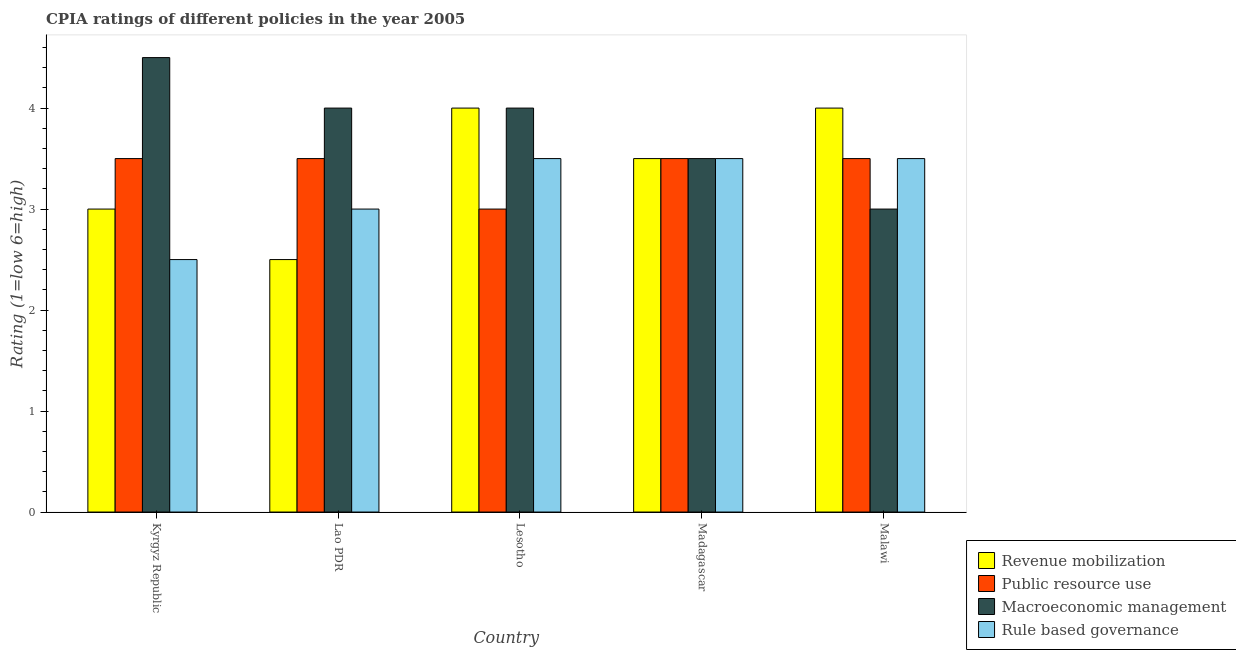How many groups of bars are there?
Your answer should be compact. 5. Are the number of bars per tick equal to the number of legend labels?
Make the answer very short. Yes. How many bars are there on the 2nd tick from the right?
Keep it short and to the point. 4. What is the label of the 4th group of bars from the left?
Give a very brief answer. Madagascar. Across all countries, what is the maximum cpia rating of public resource use?
Offer a very short reply. 3.5. In which country was the cpia rating of revenue mobilization maximum?
Make the answer very short. Lesotho. In which country was the cpia rating of rule based governance minimum?
Offer a terse response. Kyrgyz Republic. What is the total cpia rating of revenue mobilization in the graph?
Give a very brief answer. 17. What is the difference between the cpia rating of public resource use and cpia rating of macroeconomic management in Lesotho?
Provide a short and direct response. -1. In how many countries, is the cpia rating of macroeconomic management greater than 3.2 ?
Provide a succinct answer. 4. What is the ratio of the cpia rating of rule based governance in Lao PDR to that in Lesotho?
Provide a short and direct response. 0.86. Is the cpia rating of revenue mobilization in Kyrgyz Republic less than that in Lesotho?
Make the answer very short. Yes. What is the difference between the highest and the second highest cpia rating of revenue mobilization?
Offer a very short reply. 0. In how many countries, is the cpia rating of macroeconomic management greater than the average cpia rating of macroeconomic management taken over all countries?
Your response must be concise. 3. Is the sum of the cpia rating of public resource use in Kyrgyz Republic and Lesotho greater than the maximum cpia rating of rule based governance across all countries?
Give a very brief answer. Yes. What does the 2nd bar from the left in Kyrgyz Republic represents?
Ensure brevity in your answer.  Public resource use. What does the 2nd bar from the right in Kyrgyz Republic represents?
Provide a succinct answer. Macroeconomic management. Is it the case that in every country, the sum of the cpia rating of revenue mobilization and cpia rating of public resource use is greater than the cpia rating of macroeconomic management?
Keep it short and to the point. Yes. How many bars are there?
Offer a very short reply. 20. Are all the bars in the graph horizontal?
Keep it short and to the point. No. How many countries are there in the graph?
Ensure brevity in your answer.  5. What is the difference between two consecutive major ticks on the Y-axis?
Offer a very short reply. 1. Are the values on the major ticks of Y-axis written in scientific E-notation?
Offer a terse response. No. Where does the legend appear in the graph?
Provide a short and direct response. Bottom right. How many legend labels are there?
Your answer should be very brief. 4. What is the title of the graph?
Offer a very short reply. CPIA ratings of different policies in the year 2005. Does "Others" appear as one of the legend labels in the graph?
Provide a short and direct response. No. What is the label or title of the X-axis?
Your response must be concise. Country. What is the label or title of the Y-axis?
Provide a succinct answer. Rating (1=low 6=high). What is the Rating (1=low 6=high) of Revenue mobilization in Kyrgyz Republic?
Provide a short and direct response. 3. What is the Rating (1=low 6=high) in Revenue mobilization in Lao PDR?
Provide a succinct answer. 2.5. What is the Rating (1=low 6=high) in Public resource use in Lao PDR?
Your response must be concise. 3.5. What is the Rating (1=low 6=high) of Macroeconomic management in Lesotho?
Make the answer very short. 4. What is the Rating (1=low 6=high) of Rule based governance in Lesotho?
Your answer should be very brief. 3.5. What is the Rating (1=low 6=high) of Revenue mobilization in Madagascar?
Your answer should be very brief. 3.5. What is the Rating (1=low 6=high) of Public resource use in Malawi?
Your response must be concise. 3.5. What is the Rating (1=low 6=high) of Rule based governance in Malawi?
Provide a short and direct response. 3.5. Across all countries, what is the minimum Rating (1=low 6=high) in Revenue mobilization?
Offer a very short reply. 2.5. Across all countries, what is the minimum Rating (1=low 6=high) of Macroeconomic management?
Keep it short and to the point. 3. Across all countries, what is the minimum Rating (1=low 6=high) in Rule based governance?
Ensure brevity in your answer.  2.5. What is the total Rating (1=low 6=high) in Revenue mobilization in the graph?
Give a very brief answer. 17. What is the total Rating (1=low 6=high) of Public resource use in the graph?
Offer a terse response. 17. What is the total Rating (1=low 6=high) in Macroeconomic management in the graph?
Offer a terse response. 19. What is the difference between the Rating (1=low 6=high) in Revenue mobilization in Kyrgyz Republic and that in Lao PDR?
Offer a terse response. 0.5. What is the difference between the Rating (1=low 6=high) in Public resource use in Kyrgyz Republic and that in Lesotho?
Make the answer very short. 0.5. What is the difference between the Rating (1=low 6=high) in Macroeconomic management in Kyrgyz Republic and that in Lesotho?
Your answer should be very brief. 0.5. What is the difference between the Rating (1=low 6=high) of Rule based governance in Kyrgyz Republic and that in Lesotho?
Ensure brevity in your answer.  -1. What is the difference between the Rating (1=low 6=high) of Revenue mobilization in Kyrgyz Republic and that in Madagascar?
Your answer should be very brief. -0.5. What is the difference between the Rating (1=low 6=high) in Macroeconomic management in Kyrgyz Republic and that in Madagascar?
Provide a short and direct response. 1. What is the difference between the Rating (1=low 6=high) in Rule based governance in Kyrgyz Republic and that in Madagascar?
Give a very brief answer. -1. What is the difference between the Rating (1=low 6=high) of Public resource use in Kyrgyz Republic and that in Malawi?
Provide a succinct answer. 0. What is the difference between the Rating (1=low 6=high) in Macroeconomic management in Kyrgyz Republic and that in Malawi?
Your answer should be very brief. 1.5. What is the difference between the Rating (1=low 6=high) in Revenue mobilization in Lao PDR and that in Lesotho?
Provide a succinct answer. -1.5. What is the difference between the Rating (1=low 6=high) of Public resource use in Lao PDR and that in Lesotho?
Keep it short and to the point. 0.5. What is the difference between the Rating (1=low 6=high) of Macroeconomic management in Lao PDR and that in Lesotho?
Your answer should be compact. 0. What is the difference between the Rating (1=low 6=high) of Rule based governance in Lao PDR and that in Lesotho?
Your response must be concise. -0.5. What is the difference between the Rating (1=low 6=high) in Public resource use in Lao PDR and that in Malawi?
Make the answer very short. 0. What is the difference between the Rating (1=low 6=high) in Macroeconomic management in Lao PDR and that in Malawi?
Give a very brief answer. 1. What is the difference between the Rating (1=low 6=high) of Macroeconomic management in Lesotho and that in Madagascar?
Offer a very short reply. 0.5. What is the difference between the Rating (1=low 6=high) in Macroeconomic management in Lesotho and that in Malawi?
Your response must be concise. 1. What is the difference between the Rating (1=low 6=high) in Macroeconomic management in Madagascar and that in Malawi?
Your answer should be compact. 0.5. What is the difference between the Rating (1=low 6=high) of Public resource use in Kyrgyz Republic and the Rating (1=low 6=high) of Macroeconomic management in Lao PDR?
Offer a very short reply. -0.5. What is the difference between the Rating (1=low 6=high) in Revenue mobilization in Kyrgyz Republic and the Rating (1=low 6=high) in Rule based governance in Lesotho?
Keep it short and to the point. -0.5. What is the difference between the Rating (1=low 6=high) in Public resource use in Kyrgyz Republic and the Rating (1=low 6=high) in Macroeconomic management in Lesotho?
Provide a short and direct response. -0.5. What is the difference between the Rating (1=low 6=high) of Public resource use in Kyrgyz Republic and the Rating (1=low 6=high) of Rule based governance in Lesotho?
Keep it short and to the point. 0. What is the difference between the Rating (1=low 6=high) in Revenue mobilization in Kyrgyz Republic and the Rating (1=low 6=high) in Macroeconomic management in Madagascar?
Offer a very short reply. -0.5. What is the difference between the Rating (1=low 6=high) of Public resource use in Kyrgyz Republic and the Rating (1=low 6=high) of Rule based governance in Madagascar?
Provide a succinct answer. 0. What is the difference between the Rating (1=low 6=high) of Macroeconomic management in Kyrgyz Republic and the Rating (1=low 6=high) of Rule based governance in Madagascar?
Provide a short and direct response. 1. What is the difference between the Rating (1=low 6=high) in Revenue mobilization in Kyrgyz Republic and the Rating (1=low 6=high) in Macroeconomic management in Malawi?
Offer a very short reply. 0. What is the difference between the Rating (1=low 6=high) of Public resource use in Kyrgyz Republic and the Rating (1=low 6=high) of Macroeconomic management in Malawi?
Give a very brief answer. 0.5. What is the difference between the Rating (1=low 6=high) of Public resource use in Kyrgyz Republic and the Rating (1=low 6=high) of Rule based governance in Malawi?
Your answer should be compact. 0. What is the difference between the Rating (1=low 6=high) of Macroeconomic management in Kyrgyz Republic and the Rating (1=low 6=high) of Rule based governance in Malawi?
Provide a succinct answer. 1. What is the difference between the Rating (1=low 6=high) in Revenue mobilization in Lao PDR and the Rating (1=low 6=high) in Public resource use in Lesotho?
Provide a succinct answer. -0.5. What is the difference between the Rating (1=low 6=high) of Revenue mobilization in Lao PDR and the Rating (1=low 6=high) of Macroeconomic management in Lesotho?
Your answer should be compact. -1.5. What is the difference between the Rating (1=low 6=high) in Macroeconomic management in Lao PDR and the Rating (1=low 6=high) in Rule based governance in Lesotho?
Your answer should be compact. 0.5. What is the difference between the Rating (1=low 6=high) in Revenue mobilization in Lao PDR and the Rating (1=low 6=high) in Public resource use in Madagascar?
Offer a terse response. -1. What is the difference between the Rating (1=low 6=high) in Revenue mobilization in Lao PDR and the Rating (1=low 6=high) in Rule based governance in Madagascar?
Your answer should be compact. -1. What is the difference between the Rating (1=low 6=high) of Public resource use in Lao PDR and the Rating (1=low 6=high) of Macroeconomic management in Madagascar?
Provide a succinct answer. 0. What is the difference between the Rating (1=low 6=high) of Public resource use in Lao PDR and the Rating (1=low 6=high) of Rule based governance in Madagascar?
Give a very brief answer. 0. What is the difference between the Rating (1=low 6=high) of Macroeconomic management in Lao PDR and the Rating (1=low 6=high) of Rule based governance in Madagascar?
Keep it short and to the point. 0.5. What is the difference between the Rating (1=low 6=high) of Revenue mobilization in Lao PDR and the Rating (1=low 6=high) of Rule based governance in Malawi?
Keep it short and to the point. -1. What is the difference between the Rating (1=low 6=high) of Macroeconomic management in Lao PDR and the Rating (1=low 6=high) of Rule based governance in Malawi?
Keep it short and to the point. 0.5. What is the difference between the Rating (1=low 6=high) in Revenue mobilization in Lesotho and the Rating (1=low 6=high) in Macroeconomic management in Madagascar?
Give a very brief answer. 0.5. What is the difference between the Rating (1=low 6=high) of Revenue mobilization in Lesotho and the Rating (1=low 6=high) of Rule based governance in Madagascar?
Provide a succinct answer. 0.5. What is the difference between the Rating (1=low 6=high) in Macroeconomic management in Lesotho and the Rating (1=low 6=high) in Rule based governance in Madagascar?
Your answer should be very brief. 0.5. What is the difference between the Rating (1=low 6=high) of Revenue mobilization in Lesotho and the Rating (1=low 6=high) of Macroeconomic management in Malawi?
Make the answer very short. 1. What is the difference between the Rating (1=low 6=high) in Public resource use in Lesotho and the Rating (1=low 6=high) in Macroeconomic management in Malawi?
Your answer should be very brief. 0. What is the difference between the Rating (1=low 6=high) of Revenue mobilization in Madagascar and the Rating (1=low 6=high) of Public resource use in Malawi?
Offer a very short reply. 0. What is the difference between the Rating (1=low 6=high) in Public resource use in Madagascar and the Rating (1=low 6=high) in Macroeconomic management in Malawi?
Offer a terse response. 0.5. What is the average Rating (1=low 6=high) in Revenue mobilization per country?
Your response must be concise. 3.4. What is the average Rating (1=low 6=high) of Macroeconomic management per country?
Offer a terse response. 3.8. What is the average Rating (1=low 6=high) in Rule based governance per country?
Your response must be concise. 3.2. What is the difference between the Rating (1=low 6=high) in Revenue mobilization and Rating (1=low 6=high) in Public resource use in Kyrgyz Republic?
Give a very brief answer. -0.5. What is the difference between the Rating (1=low 6=high) in Revenue mobilization and Rating (1=low 6=high) in Rule based governance in Kyrgyz Republic?
Ensure brevity in your answer.  0.5. What is the difference between the Rating (1=low 6=high) of Public resource use and Rating (1=low 6=high) of Macroeconomic management in Kyrgyz Republic?
Provide a short and direct response. -1. What is the difference between the Rating (1=low 6=high) in Revenue mobilization and Rating (1=low 6=high) in Macroeconomic management in Lao PDR?
Offer a very short reply. -1.5. What is the difference between the Rating (1=low 6=high) of Public resource use and Rating (1=low 6=high) of Macroeconomic management in Lao PDR?
Give a very brief answer. -0.5. What is the difference between the Rating (1=low 6=high) of Macroeconomic management and Rating (1=low 6=high) of Rule based governance in Lao PDR?
Offer a very short reply. 1. What is the difference between the Rating (1=low 6=high) in Revenue mobilization and Rating (1=low 6=high) in Public resource use in Lesotho?
Ensure brevity in your answer.  1. What is the difference between the Rating (1=low 6=high) in Revenue mobilization and Rating (1=low 6=high) in Rule based governance in Lesotho?
Make the answer very short. 0.5. What is the difference between the Rating (1=low 6=high) of Macroeconomic management and Rating (1=low 6=high) of Rule based governance in Lesotho?
Give a very brief answer. 0.5. What is the difference between the Rating (1=low 6=high) in Revenue mobilization and Rating (1=low 6=high) in Macroeconomic management in Madagascar?
Ensure brevity in your answer.  0. What is the difference between the Rating (1=low 6=high) in Revenue mobilization and Rating (1=low 6=high) in Rule based governance in Madagascar?
Give a very brief answer. 0. What is the difference between the Rating (1=low 6=high) of Revenue mobilization and Rating (1=low 6=high) of Public resource use in Malawi?
Make the answer very short. 0.5. What is the ratio of the Rating (1=low 6=high) in Revenue mobilization in Kyrgyz Republic to that in Lao PDR?
Provide a succinct answer. 1.2. What is the ratio of the Rating (1=low 6=high) of Public resource use in Kyrgyz Republic to that in Lao PDR?
Your answer should be compact. 1. What is the ratio of the Rating (1=low 6=high) in Macroeconomic management in Kyrgyz Republic to that in Lao PDR?
Your answer should be very brief. 1.12. What is the ratio of the Rating (1=low 6=high) in Rule based governance in Kyrgyz Republic to that in Lao PDR?
Your answer should be compact. 0.83. What is the ratio of the Rating (1=low 6=high) in Revenue mobilization in Kyrgyz Republic to that in Lesotho?
Keep it short and to the point. 0.75. What is the ratio of the Rating (1=low 6=high) in Public resource use in Kyrgyz Republic to that in Lesotho?
Give a very brief answer. 1.17. What is the ratio of the Rating (1=low 6=high) of Macroeconomic management in Kyrgyz Republic to that in Lesotho?
Ensure brevity in your answer.  1.12. What is the ratio of the Rating (1=low 6=high) in Rule based governance in Kyrgyz Republic to that in Lesotho?
Make the answer very short. 0.71. What is the ratio of the Rating (1=low 6=high) of Public resource use in Kyrgyz Republic to that in Madagascar?
Give a very brief answer. 1. What is the ratio of the Rating (1=low 6=high) in Rule based governance in Kyrgyz Republic to that in Madagascar?
Your answer should be very brief. 0.71. What is the ratio of the Rating (1=low 6=high) of Macroeconomic management in Lao PDR to that in Lesotho?
Your response must be concise. 1. What is the ratio of the Rating (1=low 6=high) of Revenue mobilization in Lao PDR to that in Malawi?
Keep it short and to the point. 0.62. What is the ratio of the Rating (1=low 6=high) in Revenue mobilization in Lesotho to that in Madagascar?
Your answer should be compact. 1.14. What is the ratio of the Rating (1=low 6=high) in Public resource use in Lesotho to that in Madagascar?
Ensure brevity in your answer.  0.86. What is the ratio of the Rating (1=low 6=high) in Macroeconomic management in Lesotho to that in Madagascar?
Your answer should be very brief. 1.14. What is the ratio of the Rating (1=low 6=high) in Rule based governance in Lesotho to that in Madagascar?
Provide a succinct answer. 1. What is the ratio of the Rating (1=low 6=high) of Public resource use in Lesotho to that in Malawi?
Provide a succinct answer. 0.86. What is the difference between the highest and the second highest Rating (1=low 6=high) in Revenue mobilization?
Provide a succinct answer. 0. What is the difference between the highest and the second highest Rating (1=low 6=high) in Public resource use?
Provide a succinct answer. 0. What is the difference between the highest and the second highest Rating (1=low 6=high) in Macroeconomic management?
Ensure brevity in your answer.  0.5. What is the difference between the highest and the lowest Rating (1=low 6=high) in Revenue mobilization?
Your answer should be compact. 1.5. What is the difference between the highest and the lowest Rating (1=low 6=high) in Macroeconomic management?
Keep it short and to the point. 1.5. What is the difference between the highest and the lowest Rating (1=low 6=high) in Rule based governance?
Your answer should be compact. 1. 